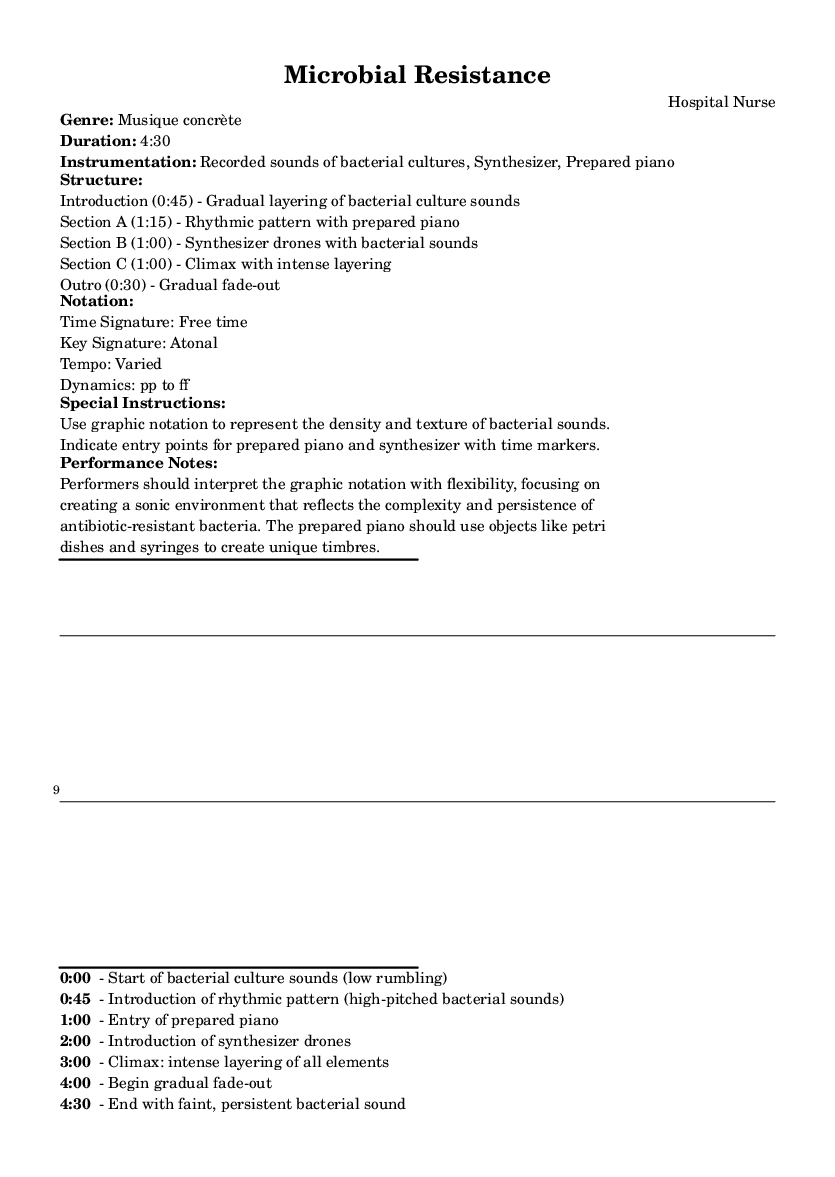What is the title of this piece? The title is 'Microbial Resistance', which is explicitly stated in the header of the sheet music.
Answer: Microbial Resistance What is the duration of the composition? The duration of the composition is 4:30, mentioned in the markup section detailing the piece's information.
Answer: 4:30 What is the key signature of this piece? There is no key signature specified as it is described as atonal, meaning it does not adhere to a traditional key system.
Answer: Atonal What is the time signature used in this piece? The time signature is noted as 'Free time', indicating that there is no strict meter and performers can interpret the rhythm flexibly.
Answer: Free time In which section does the climax occur? The climax occurs in section C, where it specifies 'Climax with intense layering', indicating that this section contains the most intense musical activity.
Answer: Section C How does the prepared piano contribute to the piece? The prepared piano uses objects like petri dishes and syringes to create unique timbres, which contributes to the overall texture of the piece as described in the performance notes.
Answer: Unique timbres What elements are combined in the climax of the piece? The climax at 3:00 combines all elements: rhythmic prepared piano, synthesizer drones, and bacterial sounds, creating intense layering, as outlined in the structure.
Answer: All elements 